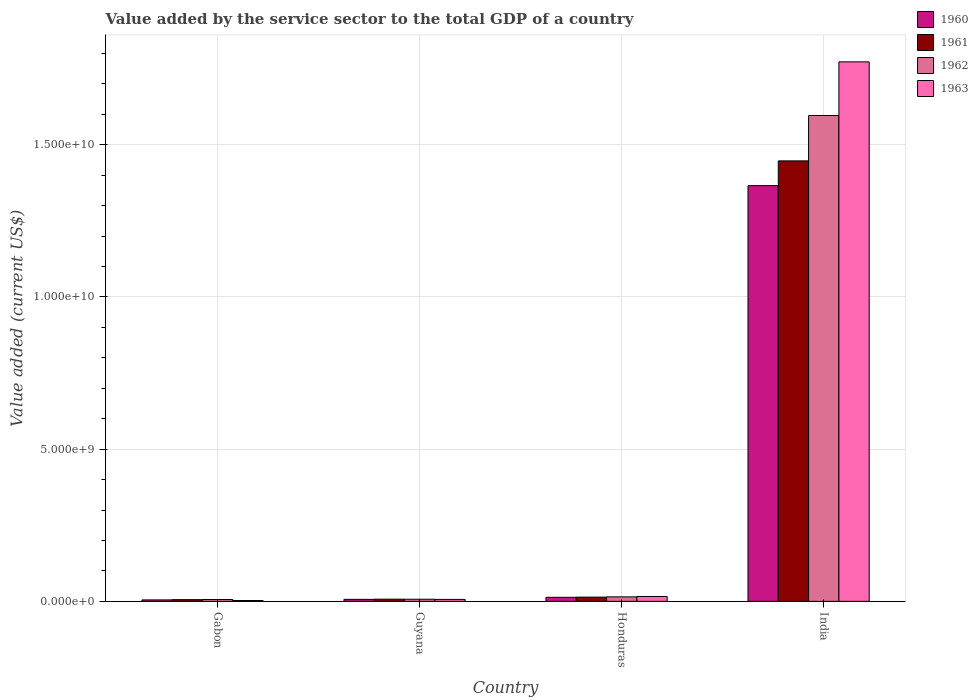How many bars are there on the 1st tick from the left?
Offer a very short reply. 4. What is the label of the 2nd group of bars from the left?
Keep it short and to the point. Guyana. What is the value added by the service sector to the total GDP in 1962 in Honduras?
Make the answer very short. 1.48e+08. Across all countries, what is the maximum value added by the service sector to the total GDP in 1961?
Offer a terse response. 1.45e+1. Across all countries, what is the minimum value added by the service sector to the total GDP in 1963?
Offer a very short reply. 2.75e+07. In which country was the value added by the service sector to the total GDP in 1960 maximum?
Your answer should be compact. India. In which country was the value added by the service sector to the total GDP in 1961 minimum?
Your answer should be compact. Gabon. What is the total value added by the service sector to the total GDP in 1963 in the graph?
Your answer should be very brief. 1.80e+1. What is the difference between the value added by the service sector to the total GDP in 1963 in Gabon and that in India?
Keep it short and to the point. -1.77e+1. What is the difference between the value added by the service sector to the total GDP in 1961 in Gabon and the value added by the service sector to the total GDP in 1963 in Guyana?
Your answer should be compact. -8.53e+06. What is the average value added by the service sector to the total GDP in 1961 per country?
Ensure brevity in your answer.  3.68e+09. What is the difference between the value added by the service sector to the total GDP of/in 1963 and value added by the service sector to the total GDP of/in 1962 in Gabon?
Provide a succinct answer. -3.38e+07. What is the ratio of the value added by the service sector to the total GDP in 1961 in Gabon to that in Honduras?
Your answer should be very brief. 0.4. Is the difference between the value added by the service sector to the total GDP in 1963 in Gabon and Honduras greater than the difference between the value added by the service sector to the total GDP in 1962 in Gabon and Honduras?
Keep it short and to the point. No. What is the difference between the highest and the second highest value added by the service sector to the total GDP in 1960?
Offer a very short reply. 6.71e+07. What is the difference between the highest and the lowest value added by the service sector to the total GDP in 1961?
Keep it short and to the point. 1.44e+1. Is the sum of the value added by the service sector to the total GDP in 1961 in Honduras and India greater than the maximum value added by the service sector to the total GDP in 1963 across all countries?
Your answer should be compact. No. What does the 3rd bar from the right in Honduras represents?
Your answer should be very brief. 1961. Is it the case that in every country, the sum of the value added by the service sector to the total GDP in 1961 and value added by the service sector to the total GDP in 1962 is greater than the value added by the service sector to the total GDP in 1963?
Offer a very short reply. Yes. How many bars are there?
Your answer should be compact. 16. Are all the bars in the graph horizontal?
Your answer should be very brief. No. Does the graph contain grids?
Offer a very short reply. Yes. How many legend labels are there?
Ensure brevity in your answer.  4. What is the title of the graph?
Your answer should be compact. Value added by the service sector to the total GDP of a country. What is the label or title of the Y-axis?
Offer a very short reply. Value added (current US$). What is the Value added (current US$) of 1960 in Gabon?
Keep it short and to the point. 4.80e+07. What is the Value added (current US$) in 1961 in Gabon?
Provide a succinct answer. 5.57e+07. What is the Value added (current US$) in 1962 in Gabon?
Make the answer very short. 6.13e+07. What is the Value added (current US$) in 1963 in Gabon?
Make the answer very short. 2.75e+07. What is the Value added (current US$) of 1960 in Guyana?
Provide a short and direct response. 6.55e+07. What is the Value added (current US$) in 1961 in Guyana?
Provide a succinct answer. 7.13e+07. What is the Value added (current US$) of 1962 in Guyana?
Provide a short and direct response. 7.03e+07. What is the Value added (current US$) of 1963 in Guyana?
Offer a very short reply. 6.42e+07. What is the Value added (current US$) in 1960 in Honduras?
Keep it short and to the point. 1.33e+08. What is the Value added (current US$) of 1961 in Honduras?
Provide a short and direct response. 1.39e+08. What is the Value added (current US$) of 1962 in Honduras?
Give a very brief answer. 1.48e+08. What is the Value added (current US$) of 1963 in Honduras?
Offer a very short reply. 1.60e+08. What is the Value added (current US$) of 1960 in India?
Give a very brief answer. 1.37e+1. What is the Value added (current US$) of 1961 in India?
Your response must be concise. 1.45e+1. What is the Value added (current US$) in 1962 in India?
Make the answer very short. 1.60e+1. What is the Value added (current US$) of 1963 in India?
Your answer should be compact. 1.77e+1. Across all countries, what is the maximum Value added (current US$) in 1960?
Provide a succinct answer. 1.37e+1. Across all countries, what is the maximum Value added (current US$) in 1961?
Keep it short and to the point. 1.45e+1. Across all countries, what is the maximum Value added (current US$) of 1962?
Your response must be concise. 1.60e+1. Across all countries, what is the maximum Value added (current US$) in 1963?
Provide a short and direct response. 1.77e+1. Across all countries, what is the minimum Value added (current US$) of 1960?
Your response must be concise. 4.80e+07. Across all countries, what is the minimum Value added (current US$) of 1961?
Your answer should be very brief. 5.57e+07. Across all countries, what is the minimum Value added (current US$) of 1962?
Your answer should be compact. 6.13e+07. Across all countries, what is the minimum Value added (current US$) of 1963?
Make the answer very short. 2.75e+07. What is the total Value added (current US$) of 1960 in the graph?
Offer a terse response. 1.39e+1. What is the total Value added (current US$) in 1961 in the graph?
Keep it short and to the point. 1.47e+1. What is the total Value added (current US$) of 1962 in the graph?
Provide a short and direct response. 1.62e+1. What is the total Value added (current US$) in 1963 in the graph?
Your response must be concise. 1.80e+1. What is the difference between the Value added (current US$) of 1960 in Gabon and that in Guyana?
Your response must be concise. -1.76e+07. What is the difference between the Value added (current US$) of 1961 in Gabon and that in Guyana?
Make the answer very short. -1.56e+07. What is the difference between the Value added (current US$) in 1962 in Gabon and that in Guyana?
Offer a very short reply. -9.03e+06. What is the difference between the Value added (current US$) in 1963 in Gabon and that in Guyana?
Your answer should be very brief. -3.68e+07. What is the difference between the Value added (current US$) of 1960 in Gabon and that in Honduras?
Make the answer very short. -8.46e+07. What is the difference between the Value added (current US$) in 1961 in Gabon and that in Honduras?
Your response must be concise. -8.31e+07. What is the difference between the Value added (current US$) of 1962 in Gabon and that in Honduras?
Your response must be concise. -8.64e+07. What is the difference between the Value added (current US$) of 1963 in Gabon and that in Honduras?
Provide a succinct answer. -1.33e+08. What is the difference between the Value added (current US$) in 1960 in Gabon and that in India?
Your answer should be compact. -1.36e+1. What is the difference between the Value added (current US$) of 1961 in Gabon and that in India?
Give a very brief answer. -1.44e+1. What is the difference between the Value added (current US$) of 1962 in Gabon and that in India?
Provide a short and direct response. -1.59e+1. What is the difference between the Value added (current US$) in 1963 in Gabon and that in India?
Your answer should be compact. -1.77e+1. What is the difference between the Value added (current US$) in 1960 in Guyana and that in Honduras?
Make the answer very short. -6.71e+07. What is the difference between the Value added (current US$) in 1961 in Guyana and that in Honduras?
Your response must be concise. -6.74e+07. What is the difference between the Value added (current US$) in 1962 in Guyana and that in Honduras?
Your answer should be compact. -7.74e+07. What is the difference between the Value added (current US$) of 1963 in Guyana and that in Honduras?
Your answer should be very brief. -9.62e+07. What is the difference between the Value added (current US$) of 1960 in Guyana and that in India?
Your answer should be compact. -1.36e+1. What is the difference between the Value added (current US$) in 1961 in Guyana and that in India?
Offer a very short reply. -1.44e+1. What is the difference between the Value added (current US$) in 1962 in Guyana and that in India?
Offer a very short reply. -1.59e+1. What is the difference between the Value added (current US$) in 1963 in Guyana and that in India?
Your answer should be compact. -1.77e+1. What is the difference between the Value added (current US$) of 1960 in Honduras and that in India?
Provide a succinct answer. -1.35e+1. What is the difference between the Value added (current US$) in 1961 in Honduras and that in India?
Your answer should be compact. -1.43e+1. What is the difference between the Value added (current US$) in 1962 in Honduras and that in India?
Offer a terse response. -1.58e+1. What is the difference between the Value added (current US$) of 1963 in Honduras and that in India?
Your answer should be very brief. -1.76e+1. What is the difference between the Value added (current US$) of 1960 in Gabon and the Value added (current US$) of 1961 in Guyana?
Keep it short and to the point. -2.34e+07. What is the difference between the Value added (current US$) of 1960 in Gabon and the Value added (current US$) of 1962 in Guyana?
Your response must be concise. -2.23e+07. What is the difference between the Value added (current US$) of 1960 in Gabon and the Value added (current US$) of 1963 in Guyana?
Make the answer very short. -1.63e+07. What is the difference between the Value added (current US$) of 1961 in Gabon and the Value added (current US$) of 1962 in Guyana?
Keep it short and to the point. -1.46e+07. What is the difference between the Value added (current US$) in 1961 in Gabon and the Value added (current US$) in 1963 in Guyana?
Keep it short and to the point. -8.53e+06. What is the difference between the Value added (current US$) in 1962 in Gabon and the Value added (current US$) in 1963 in Guyana?
Your answer should be compact. -2.96e+06. What is the difference between the Value added (current US$) of 1960 in Gabon and the Value added (current US$) of 1961 in Honduras?
Your answer should be compact. -9.08e+07. What is the difference between the Value added (current US$) in 1960 in Gabon and the Value added (current US$) in 1962 in Honduras?
Your answer should be very brief. -9.97e+07. What is the difference between the Value added (current US$) of 1960 in Gabon and the Value added (current US$) of 1963 in Honduras?
Provide a short and direct response. -1.12e+08. What is the difference between the Value added (current US$) of 1961 in Gabon and the Value added (current US$) of 1962 in Honduras?
Give a very brief answer. -9.20e+07. What is the difference between the Value added (current US$) of 1961 in Gabon and the Value added (current US$) of 1963 in Honduras?
Provide a short and direct response. -1.05e+08. What is the difference between the Value added (current US$) in 1962 in Gabon and the Value added (current US$) in 1963 in Honduras?
Your response must be concise. -9.92e+07. What is the difference between the Value added (current US$) in 1960 in Gabon and the Value added (current US$) in 1961 in India?
Ensure brevity in your answer.  -1.44e+1. What is the difference between the Value added (current US$) of 1960 in Gabon and the Value added (current US$) of 1962 in India?
Offer a very short reply. -1.59e+1. What is the difference between the Value added (current US$) of 1960 in Gabon and the Value added (current US$) of 1963 in India?
Give a very brief answer. -1.77e+1. What is the difference between the Value added (current US$) of 1961 in Gabon and the Value added (current US$) of 1962 in India?
Ensure brevity in your answer.  -1.59e+1. What is the difference between the Value added (current US$) in 1961 in Gabon and the Value added (current US$) in 1963 in India?
Provide a short and direct response. -1.77e+1. What is the difference between the Value added (current US$) of 1962 in Gabon and the Value added (current US$) of 1963 in India?
Give a very brief answer. -1.77e+1. What is the difference between the Value added (current US$) of 1960 in Guyana and the Value added (current US$) of 1961 in Honduras?
Your response must be concise. -7.32e+07. What is the difference between the Value added (current US$) in 1960 in Guyana and the Value added (current US$) in 1962 in Honduras?
Offer a terse response. -8.21e+07. What is the difference between the Value added (current US$) of 1960 in Guyana and the Value added (current US$) of 1963 in Honduras?
Your answer should be compact. -9.49e+07. What is the difference between the Value added (current US$) in 1961 in Guyana and the Value added (current US$) in 1962 in Honduras?
Keep it short and to the point. -7.63e+07. What is the difference between the Value added (current US$) of 1961 in Guyana and the Value added (current US$) of 1963 in Honduras?
Provide a succinct answer. -8.91e+07. What is the difference between the Value added (current US$) of 1962 in Guyana and the Value added (current US$) of 1963 in Honduras?
Your answer should be compact. -9.02e+07. What is the difference between the Value added (current US$) in 1960 in Guyana and the Value added (current US$) in 1961 in India?
Your answer should be very brief. -1.44e+1. What is the difference between the Value added (current US$) in 1960 in Guyana and the Value added (current US$) in 1962 in India?
Keep it short and to the point. -1.59e+1. What is the difference between the Value added (current US$) of 1960 in Guyana and the Value added (current US$) of 1963 in India?
Offer a very short reply. -1.77e+1. What is the difference between the Value added (current US$) in 1961 in Guyana and the Value added (current US$) in 1962 in India?
Give a very brief answer. -1.59e+1. What is the difference between the Value added (current US$) in 1961 in Guyana and the Value added (current US$) in 1963 in India?
Your response must be concise. -1.76e+1. What is the difference between the Value added (current US$) of 1962 in Guyana and the Value added (current US$) of 1963 in India?
Offer a terse response. -1.77e+1. What is the difference between the Value added (current US$) of 1960 in Honduras and the Value added (current US$) of 1961 in India?
Ensure brevity in your answer.  -1.43e+1. What is the difference between the Value added (current US$) in 1960 in Honduras and the Value added (current US$) in 1962 in India?
Offer a very short reply. -1.58e+1. What is the difference between the Value added (current US$) in 1960 in Honduras and the Value added (current US$) in 1963 in India?
Keep it short and to the point. -1.76e+1. What is the difference between the Value added (current US$) in 1961 in Honduras and the Value added (current US$) in 1962 in India?
Offer a terse response. -1.58e+1. What is the difference between the Value added (current US$) of 1961 in Honduras and the Value added (current US$) of 1963 in India?
Keep it short and to the point. -1.76e+1. What is the difference between the Value added (current US$) in 1962 in Honduras and the Value added (current US$) in 1963 in India?
Offer a terse response. -1.76e+1. What is the average Value added (current US$) in 1960 per country?
Offer a very short reply. 3.48e+09. What is the average Value added (current US$) of 1961 per country?
Keep it short and to the point. 3.68e+09. What is the average Value added (current US$) of 1962 per country?
Make the answer very short. 4.06e+09. What is the average Value added (current US$) of 1963 per country?
Give a very brief answer. 4.49e+09. What is the difference between the Value added (current US$) in 1960 and Value added (current US$) in 1961 in Gabon?
Offer a terse response. -7.74e+06. What is the difference between the Value added (current US$) of 1960 and Value added (current US$) of 1962 in Gabon?
Provide a short and direct response. -1.33e+07. What is the difference between the Value added (current US$) of 1960 and Value added (current US$) of 1963 in Gabon?
Offer a very short reply. 2.05e+07. What is the difference between the Value added (current US$) in 1961 and Value added (current US$) in 1962 in Gabon?
Your answer should be compact. -5.57e+06. What is the difference between the Value added (current US$) of 1961 and Value added (current US$) of 1963 in Gabon?
Provide a succinct answer. 2.82e+07. What is the difference between the Value added (current US$) in 1962 and Value added (current US$) in 1963 in Gabon?
Your answer should be very brief. 3.38e+07. What is the difference between the Value added (current US$) of 1960 and Value added (current US$) of 1961 in Guyana?
Provide a short and direct response. -5.83e+06. What is the difference between the Value added (current US$) in 1960 and Value added (current US$) in 1962 in Guyana?
Keep it short and to the point. -4.78e+06. What is the difference between the Value added (current US$) of 1960 and Value added (current US$) of 1963 in Guyana?
Your answer should be compact. 1.28e+06. What is the difference between the Value added (current US$) of 1961 and Value added (current US$) of 1962 in Guyana?
Give a very brief answer. 1.05e+06. What is the difference between the Value added (current US$) in 1961 and Value added (current US$) in 1963 in Guyana?
Provide a short and direct response. 7.12e+06. What is the difference between the Value added (current US$) in 1962 and Value added (current US$) in 1963 in Guyana?
Make the answer very short. 6.07e+06. What is the difference between the Value added (current US$) in 1960 and Value added (current US$) in 1961 in Honduras?
Your response must be concise. -6.15e+06. What is the difference between the Value added (current US$) in 1960 and Value added (current US$) in 1962 in Honduras?
Provide a succinct answer. -1.50e+07. What is the difference between the Value added (current US$) in 1960 and Value added (current US$) in 1963 in Honduras?
Keep it short and to the point. -2.78e+07. What is the difference between the Value added (current US$) in 1961 and Value added (current US$) in 1962 in Honduras?
Make the answer very short. -8.90e+06. What is the difference between the Value added (current US$) in 1961 and Value added (current US$) in 1963 in Honduras?
Your answer should be very brief. -2.17e+07. What is the difference between the Value added (current US$) of 1962 and Value added (current US$) of 1963 in Honduras?
Offer a terse response. -1.28e+07. What is the difference between the Value added (current US$) in 1960 and Value added (current US$) in 1961 in India?
Provide a succinct answer. -8.13e+08. What is the difference between the Value added (current US$) in 1960 and Value added (current US$) in 1962 in India?
Make the answer very short. -2.30e+09. What is the difference between the Value added (current US$) of 1960 and Value added (current US$) of 1963 in India?
Give a very brief answer. -4.07e+09. What is the difference between the Value added (current US$) of 1961 and Value added (current US$) of 1962 in India?
Provide a succinct answer. -1.49e+09. What is the difference between the Value added (current US$) in 1961 and Value added (current US$) in 1963 in India?
Offer a very short reply. -3.25e+09. What is the difference between the Value added (current US$) in 1962 and Value added (current US$) in 1963 in India?
Your answer should be very brief. -1.76e+09. What is the ratio of the Value added (current US$) in 1960 in Gabon to that in Guyana?
Your response must be concise. 0.73. What is the ratio of the Value added (current US$) in 1961 in Gabon to that in Guyana?
Offer a very short reply. 0.78. What is the ratio of the Value added (current US$) in 1962 in Gabon to that in Guyana?
Provide a short and direct response. 0.87. What is the ratio of the Value added (current US$) in 1963 in Gabon to that in Guyana?
Your answer should be compact. 0.43. What is the ratio of the Value added (current US$) in 1960 in Gabon to that in Honduras?
Offer a very short reply. 0.36. What is the ratio of the Value added (current US$) in 1961 in Gabon to that in Honduras?
Make the answer very short. 0.4. What is the ratio of the Value added (current US$) of 1962 in Gabon to that in Honduras?
Your answer should be very brief. 0.41. What is the ratio of the Value added (current US$) of 1963 in Gabon to that in Honduras?
Your answer should be very brief. 0.17. What is the ratio of the Value added (current US$) in 1960 in Gabon to that in India?
Your answer should be very brief. 0. What is the ratio of the Value added (current US$) of 1961 in Gabon to that in India?
Keep it short and to the point. 0. What is the ratio of the Value added (current US$) in 1962 in Gabon to that in India?
Offer a terse response. 0. What is the ratio of the Value added (current US$) in 1963 in Gabon to that in India?
Offer a very short reply. 0. What is the ratio of the Value added (current US$) in 1960 in Guyana to that in Honduras?
Offer a terse response. 0.49. What is the ratio of the Value added (current US$) of 1961 in Guyana to that in Honduras?
Your answer should be very brief. 0.51. What is the ratio of the Value added (current US$) in 1962 in Guyana to that in Honduras?
Provide a succinct answer. 0.48. What is the ratio of the Value added (current US$) in 1963 in Guyana to that in Honduras?
Your response must be concise. 0.4. What is the ratio of the Value added (current US$) of 1960 in Guyana to that in India?
Offer a very short reply. 0. What is the ratio of the Value added (current US$) of 1961 in Guyana to that in India?
Ensure brevity in your answer.  0. What is the ratio of the Value added (current US$) of 1962 in Guyana to that in India?
Offer a very short reply. 0. What is the ratio of the Value added (current US$) of 1963 in Guyana to that in India?
Provide a succinct answer. 0. What is the ratio of the Value added (current US$) in 1960 in Honduras to that in India?
Give a very brief answer. 0.01. What is the ratio of the Value added (current US$) of 1961 in Honduras to that in India?
Make the answer very short. 0.01. What is the ratio of the Value added (current US$) in 1962 in Honduras to that in India?
Provide a succinct answer. 0.01. What is the ratio of the Value added (current US$) in 1963 in Honduras to that in India?
Give a very brief answer. 0.01. What is the difference between the highest and the second highest Value added (current US$) in 1960?
Keep it short and to the point. 1.35e+1. What is the difference between the highest and the second highest Value added (current US$) of 1961?
Provide a short and direct response. 1.43e+1. What is the difference between the highest and the second highest Value added (current US$) of 1962?
Provide a short and direct response. 1.58e+1. What is the difference between the highest and the second highest Value added (current US$) of 1963?
Keep it short and to the point. 1.76e+1. What is the difference between the highest and the lowest Value added (current US$) of 1960?
Your answer should be compact. 1.36e+1. What is the difference between the highest and the lowest Value added (current US$) in 1961?
Keep it short and to the point. 1.44e+1. What is the difference between the highest and the lowest Value added (current US$) of 1962?
Offer a very short reply. 1.59e+1. What is the difference between the highest and the lowest Value added (current US$) of 1963?
Your response must be concise. 1.77e+1. 